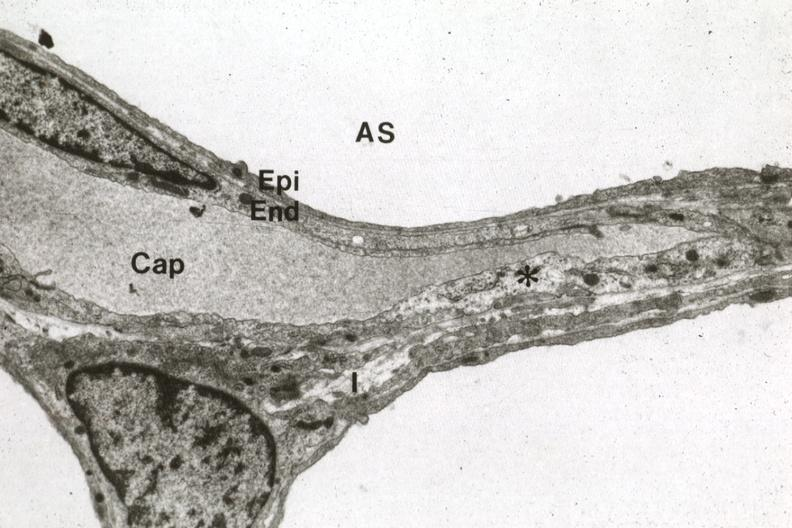what is present?
Answer the question using a single word or phrase. Respiratory 